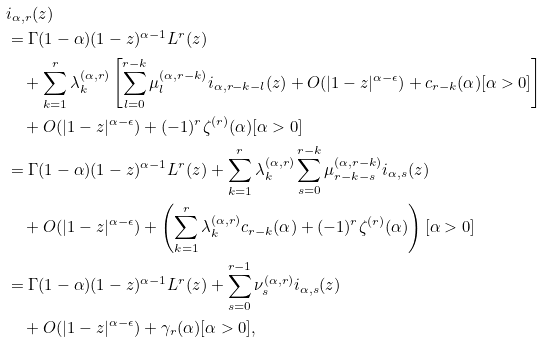Convert formula to latex. <formula><loc_0><loc_0><loc_500><loc_500>& \L i _ { \alpha , r } ( z ) \\ & = \Gamma ( 1 - \alpha ) ( 1 - z ) ^ { \alpha - 1 } L ^ { r } ( z ) \\ & \quad + \sum _ { k = 1 } ^ { r } \lambda _ { k } ^ { ( \alpha , r ) } \left [ \sum _ { l = 0 } ^ { r - k } \mu _ { l } ^ { ( \alpha , r - k ) } \L i _ { \alpha , r - k - l } ( z ) + O ( | 1 - z | ^ { \alpha - \epsilon } ) + c _ { r - k } ( \alpha ) [ \alpha > 0 ] \right ] \\ & \quad + O ( | 1 - z | ^ { \alpha - \epsilon } ) + ( - 1 ) ^ { r } \zeta ^ { ( r ) } ( \alpha ) [ \alpha > 0 ] \\ & = \Gamma ( 1 - \alpha ) ( 1 - z ) ^ { \alpha - 1 } L ^ { r } ( z ) + \sum _ { k = 1 } ^ { r } \lambda _ { k } ^ { ( \alpha , r ) } \sum _ { s = 0 } ^ { r - k } \mu _ { r - k - s } ^ { ( \alpha , r - k ) } \L i _ { \alpha , s } ( z ) \\ & \quad + O ( | 1 - z | ^ { \alpha - \epsilon } ) + \left ( \sum _ { k = 1 } ^ { r } \lambda _ { k } ^ { ( \alpha , r ) } c _ { r - k } ( \alpha ) + ( - 1 ) ^ { r } \zeta ^ { ( r ) } ( \alpha ) \right ) [ \alpha > 0 ] \\ & = \Gamma ( 1 - \alpha ) ( 1 - z ) ^ { \alpha - 1 } L ^ { r } ( z ) + \sum _ { s = 0 } ^ { r - 1 } \nu _ { s } ^ { ( \alpha , r ) } \L i _ { \alpha , s } ( z ) \\ & \quad + O ( | 1 - z | ^ { \alpha - \epsilon } ) + \gamma _ { r } ( \alpha ) [ \alpha > 0 ] ,</formula> 